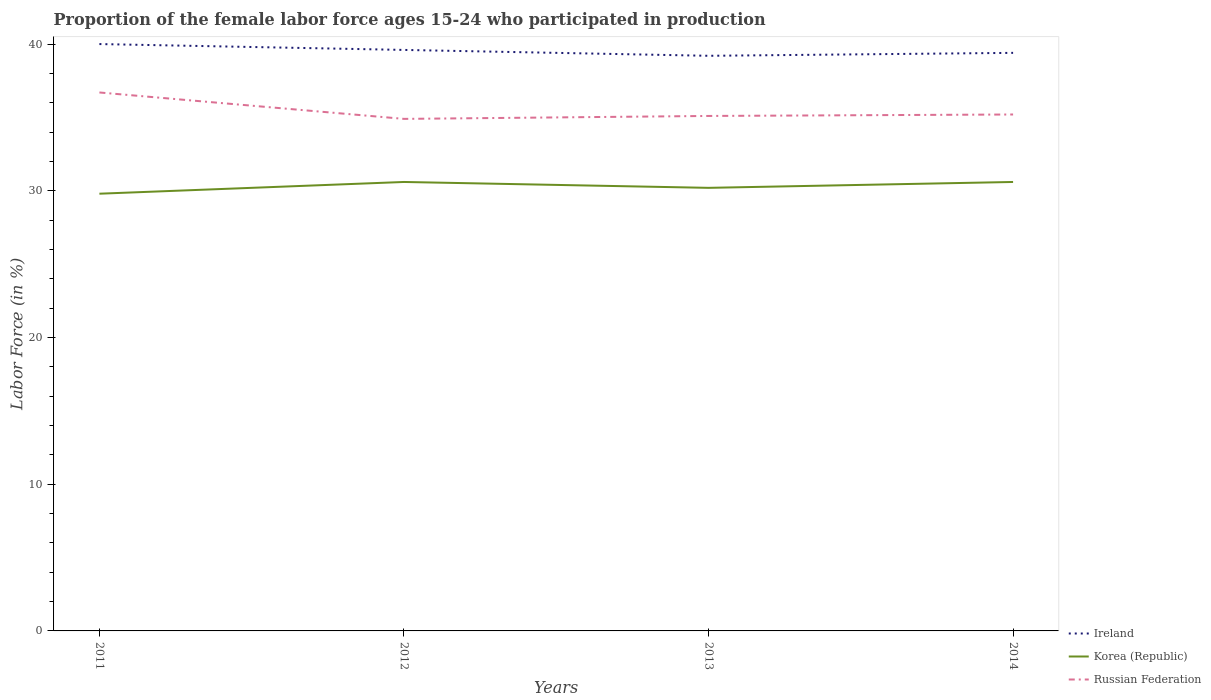Does the line corresponding to Korea (Republic) intersect with the line corresponding to Russian Federation?
Provide a succinct answer. No. Is the number of lines equal to the number of legend labels?
Offer a very short reply. Yes. Across all years, what is the maximum proportion of the female labor force who participated in production in Ireland?
Keep it short and to the point. 39.2. In which year was the proportion of the female labor force who participated in production in Korea (Republic) maximum?
Make the answer very short. 2011. What is the total proportion of the female labor force who participated in production in Russian Federation in the graph?
Your answer should be compact. -0.1. What is the difference between the highest and the second highest proportion of the female labor force who participated in production in Russian Federation?
Give a very brief answer. 1.8. What is the difference between the highest and the lowest proportion of the female labor force who participated in production in Korea (Republic)?
Keep it short and to the point. 2. How many years are there in the graph?
Give a very brief answer. 4. Are the values on the major ticks of Y-axis written in scientific E-notation?
Keep it short and to the point. No. How many legend labels are there?
Give a very brief answer. 3. How are the legend labels stacked?
Provide a short and direct response. Vertical. What is the title of the graph?
Ensure brevity in your answer.  Proportion of the female labor force ages 15-24 who participated in production. Does "Moldova" appear as one of the legend labels in the graph?
Offer a terse response. No. What is the label or title of the Y-axis?
Your answer should be very brief. Labor Force (in %). What is the Labor Force (in %) of Ireland in 2011?
Your answer should be compact. 40. What is the Labor Force (in %) in Korea (Republic) in 2011?
Keep it short and to the point. 29.8. What is the Labor Force (in %) in Russian Federation in 2011?
Ensure brevity in your answer.  36.7. What is the Labor Force (in %) in Ireland in 2012?
Provide a short and direct response. 39.6. What is the Labor Force (in %) in Korea (Republic) in 2012?
Your response must be concise. 30.6. What is the Labor Force (in %) of Russian Federation in 2012?
Give a very brief answer. 34.9. What is the Labor Force (in %) of Ireland in 2013?
Provide a succinct answer. 39.2. What is the Labor Force (in %) in Korea (Republic) in 2013?
Your answer should be very brief. 30.2. What is the Labor Force (in %) of Russian Federation in 2013?
Offer a terse response. 35.1. What is the Labor Force (in %) of Ireland in 2014?
Keep it short and to the point. 39.4. What is the Labor Force (in %) in Korea (Republic) in 2014?
Ensure brevity in your answer.  30.6. What is the Labor Force (in %) of Russian Federation in 2014?
Provide a succinct answer. 35.2. Across all years, what is the maximum Labor Force (in %) in Ireland?
Your answer should be compact. 40. Across all years, what is the maximum Labor Force (in %) in Korea (Republic)?
Ensure brevity in your answer.  30.6. Across all years, what is the maximum Labor Force (in %) of Russian Federation?
Your answer should be compact. 36.7. Across all years, what is the minimum Labor Force (in %) in Ireland?
Your response must be concise. 39.2. Across all years, what is the minimum Labor Force (in %) of Korea (Republic)?
Your response must be concise. 29.8. Across all years, what is the minimum Labor Force (in %) in Russian Federation?
Provide a succinct answer. 34.9. What is the total Labor Force (in %) of Ireland in the graph?
Offer a terse response. 158.2. What is the total Labor Force (in %) in Korea (Republic) in the graph?
Ensure brevity in your answer.  121.2. What is the total Labor Force (in %) in Russian Federation in the graph?
Provide a succinct answer. 141.9. What is the difference between the Labor Force (in %) in Ireland in 2011 and that in 2013?
Give a very brief answer. 0.8. What is the difference between the Labor Force (in %) in Korea (Republic) in 2011 and that in 2013?
Your answer should be very brief. -0.4. What is the difference between the Labor Force (in %) of Russian Federation in 2011 and that in 2013?
Make the answer very short. 1.6. What is the difference between the Labor Force (in %) of Ireland in 2011 and that in 2014?
Your response must be concise. 0.6. What is the difference between the Labor Force (in %) of Korea (Republic) in 2011 and that in 2014?
Keep it short and to the point. -0.8. What is the difference between the Labor Force (in %) in Korea (Republic) in 2012 and that in 2013?
Your answer should be compact. 0.4. What is the difference between the Labor Force (in %) of Russian Federation in 2012 and that in 2013?
Your answer should be compact. -0.2. What is the difference between the Labor Force (in %) of Ireland in 2012 and that in 2014?
Offer a very short reply. 0.2. What is the difference between the Labor Force (in %) in Korea (Republic) in 2012 and that in 2014?
Make the answer very short. 0. What is the difference between the Labor Force (in %) of Ireland in 2013 and that in 2014?
Offer a very short reply. -0.2. What is the difference between the Labor Force (in %) in Russian Federation in 2013 and that in 2014?
Provide a short and direct response. -0.1. What is the difference between the Labor Force (in %) in Ireland in 2011 and the Labor Force (in %) in Korea (Republic) in 2012?
Offer a very short reply. 9.4. What is the difference between the Labor Force (in %) of Ireland in 2011 and the Labor Force (in %) of Russian Federation in 2012?
Ensure brevity in your answer.  5.1. What is the difference between the Labor Force (in %) in Korea (Republic) in 2011 and the Labor Force (in %) in Russian Federation in 2012?
Your response must be concise. -5.1. What is the difference between the Labor Force (in %) in Ireland in 2011 and the Labor Force (in %) in Korea (Republic) in 2013?
Your answer should be very brief. 9.8. What is the difference between the Labor Force (in %) of Ireland in 2011 and the Labor Force (in %) of Russian Federation in 2013?
Offer a very short reply. 4.9. What is the difference between the Labor Force (in %) of Ireland in 2011 and the Labor Force (in %) of Russian Federation in 2014?
Your response must be concise. 4.8. What is the difference between the Labor Force (in %) in Ireland in 2012 and the Labor Force (in %) in Korea (Republic) in 2013?
Ensure brevity in your answer.  9.4. What is the difference between the Labor Force (in %) in Korea (Republic) in 2012 and the Labor Force (in %) in Russian Federation in 2013?
Your response must be concise. -4.5. What is the difference between the Labor Force (in %) in Korea (Republic) in 2012 and the Labor Force (in %) in Russian Federation in 2014?
Make the answer very short. -4.6. What is the difference between the Labor Force (in %) of Ireland in 2013 and the Labor Force (in %) of Korea (Republic) in 2014?
Your answer should be very brief. 8.6. What is the average Labor Force (in %) of Ireland per year?
Your answer should be compact. 39.55. What is the average Labor Force (in %) in Korea (Republic) per year?
Offer a very short reply. 30.3. What is the average Labor Force (in %) of Russian Federation per year?
Your response must be concise. 35.48. In the year 2011, what is the difference between the Labor Force (in %) in Ireland and Labor Force (in %) in Korea (Republic)?
Ensure brevity in your answer.  10.2. In the year 2012, what is the difference between the Labor Force (in %) of Korea (Republic) and Labor Force (in %) of Russian Federation?
Provide a short and direct response. -4.3. In the year 2013, what is the difference between the Labor Force (in %) of Ireland and Labor Force (in %) of Korea (Republic)?
Ensure brevity in your answer.  9. In the year 2014, what is the difference between the Labor Force (in %) in Korea (Republic) and Labor Force (in %) in Russian Federation?
Your response must be concise. -4.6. What is the ratio of the Labor Force (in %) of Korea (Republic) in 2011 to that in 2012?
Keep it short and to the point. 0.97. What is the ratio of the Labor Force (in %) in Russian Federation in 2011 to that in 2012?
Make the answer very short. 1.05. What is the ratio of the Labor Force (in %) in Ireland in 2011 to that in 2013?
Provide a succinct answer. 1.02. What is the ratio of the Labor Force (in %) in Russian Federation in 2011 to that in 2013?
Your answer should be very brief. 1.05. What is the ratio of the Labor Force (in %) of Ireland in 2011 to that in 2014?
Offer a terse response. 1.02. What is the ratio of the Labor Force (in %) of Korea (Republic) in 2011 to that in 2014?
Your response must be concise. 0.97. What is the ratio of the Labor Force (in %) in Russian Federation in 2011 to that in 2014?
Your answer should be compact. 1.04. What is the ratio of the Labor Force (in %) in Ireland in 2012 to that in 2013?
Your answer should be very brief. 1.01. What is the ratio of the Labor Force (in %) in Korea (Republic) in 2012 to that in 2013?
Keep it short and to the point. 1.01. What is the ratio of the Labor Force (in %) of Russian Federation in 2012 to that in 2013?
Keep it short and to the point. 0.99. What is the ratio of the Labor Force (in %) in Ireland in 2012 to that in 2014?
Provide a short and direct response. 1.01. What is the ratio of the Labor Force (in %) of Korea (Republic) in 2012 to that in 2014?
Your answer should be compact. 1. What is the ratio of the Labor Force (in %) of Ireland in 2013 to that in 2014?
Keep it short and to the point. 0.99. What is the ratio of the Labor Force (in %) in Korea (Republic) in 2013 to that in 2014?
Give a very brief answer. 0.99. What is the difference between the highest and the second highest Labor Force (in %) of Ireland?
Offer a terse response. 0.4. What is the difference between the highest and the second highest Labor Force (in %) in Korea (Republic)?
Provide a succinct answer. 0. What is the difference between the highest and the second highest Labor Force (in %) of Russian Federation?
Ensure brevity in your answer.  1.5. 